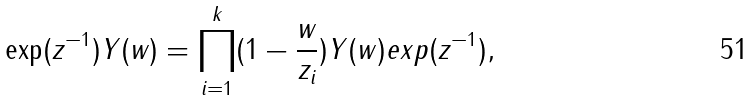<formula> <loc_0><loc_0><loc_500><loc_500>\exp ( z ^ { - 1 } ) Y ( w ) = \prod ^ { k } _ { i = 1 } ( 1 - \frac { w } { z _ { i } } ) Y ( w ) e x p ( z ^ { - 1 } ) ,</formula> 